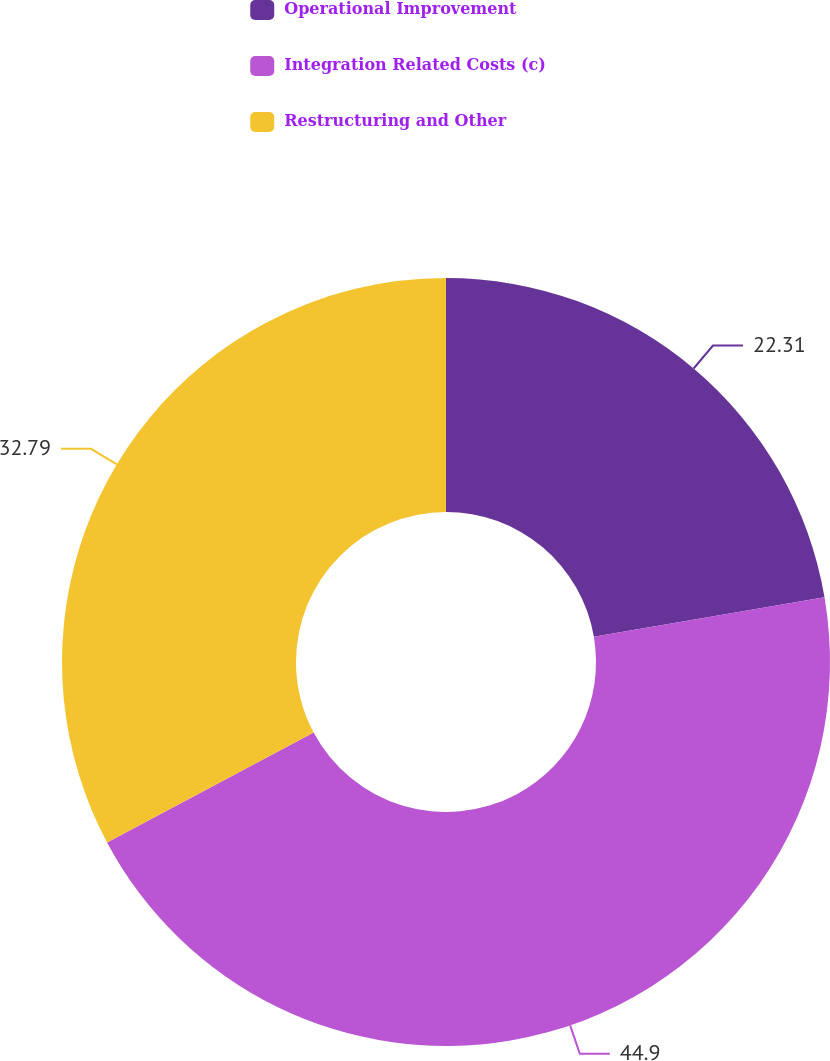Convert chart. <chart><loc_0><loc_0><loc_500><loc_500><pie_chart><fcel>Operational Improvement<fcel>Integration Related Costs (c)<fcel>Restructuring and Other<nl><fcel>22.31%<fcel>44.91%<fcel>32.79%<nl></chart> 